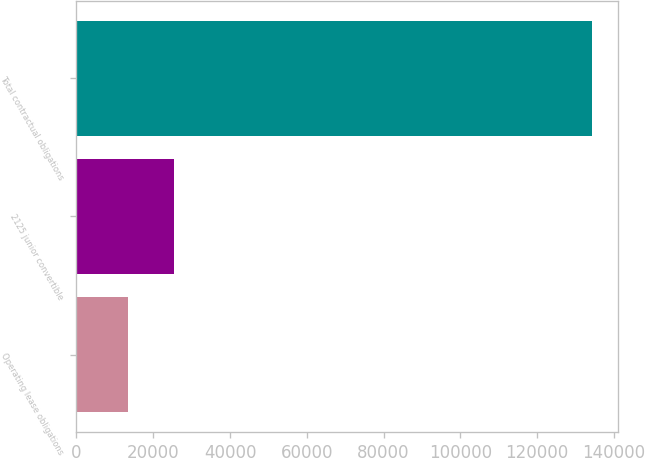<chart> <loc_0><loc_0><loc_500><loc_500><bar_chart><fcel>Operating lease obligations<fcel>2125 junior convertible<fcel>Total contractual obligations<nl><fcel>13344<fcel>25445.4<fcel>134358<nl></chart> 